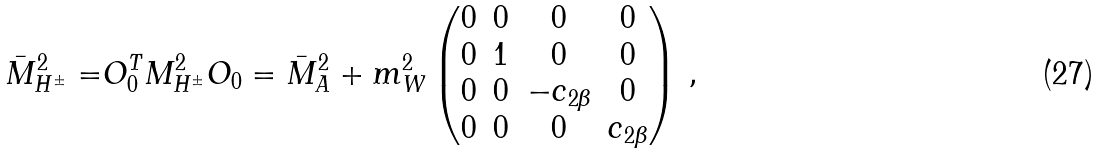Convert formula to latex. <formula><loc_0><loc_0><loc_500><loc_500>\bar { M } _ { H ^ { \pm } } ^ { 2 } = & O _ { 0 } ^ { T } M _ { H ^ { \pm } } ^ { 2 } O _ { 0 } = \bar { M } _ { A } ^ { 2 } + m _ { W } ^ { 2 } \begin{pmatrix} 0 & 0 & 0 & 0 \\ 0 & 1 & 0 & 0 \\ 0 & 0 & - c _ { 2 \beta } & 0 \\ 0 & 0 & 0 & c _ { 2 \beta } \end{pmatrix} \, ,</formula> 